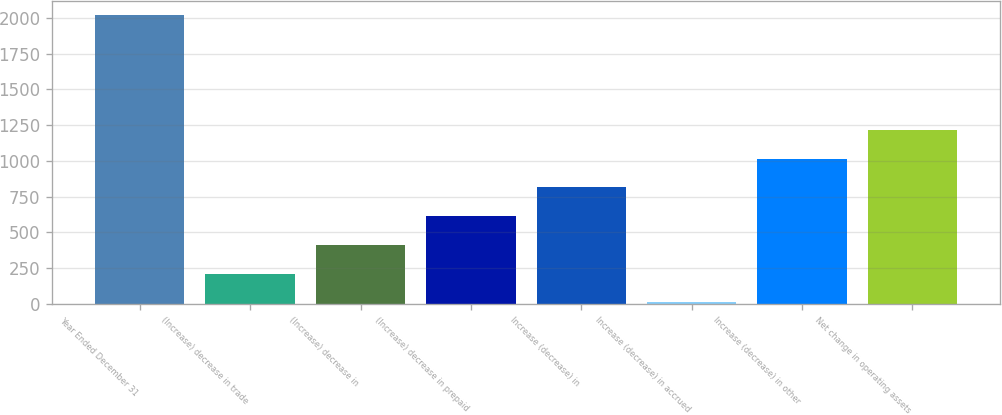Convert chart to OTSL. <chart><loc_0><loc_0><loc_500><loc_500><bar_chart><fcel>Year Ended December 31<fcel>(Increase) decrease in trade<fcel>(Increase) decrease in<fcel>(Increase) decrease in prepaid<fcel>Increase (decrease) in<fcel>Increase (decrease) in accrued<fcel>Increase (decrease) in other<fcel>Net change in operating assets<nl><fcel>2018<fcel>212.6<fcel>413.2<fcel>613.8<fcel>814.4<fcel>12<fcel>1015<fcel>1215.6<nl></chart> 